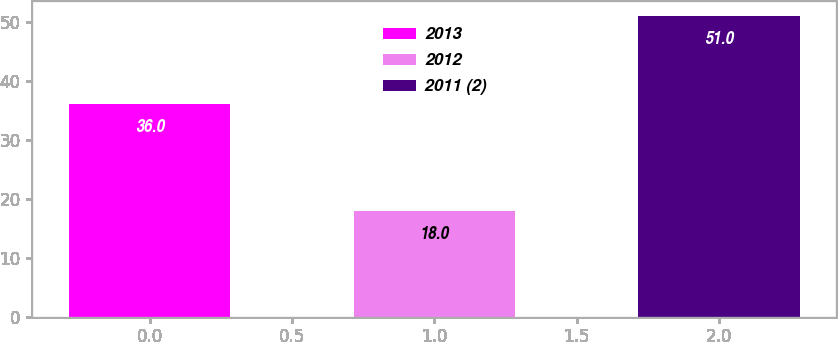Convert chart to OTSL. <chart><loc_0><loc_0><loc_500><loc_500><bar_chart><fcel>2013<fcel>2012<fcel>2011 (2)<nl><fcel>36<fcel>18<fcel>51<nl></chart> 